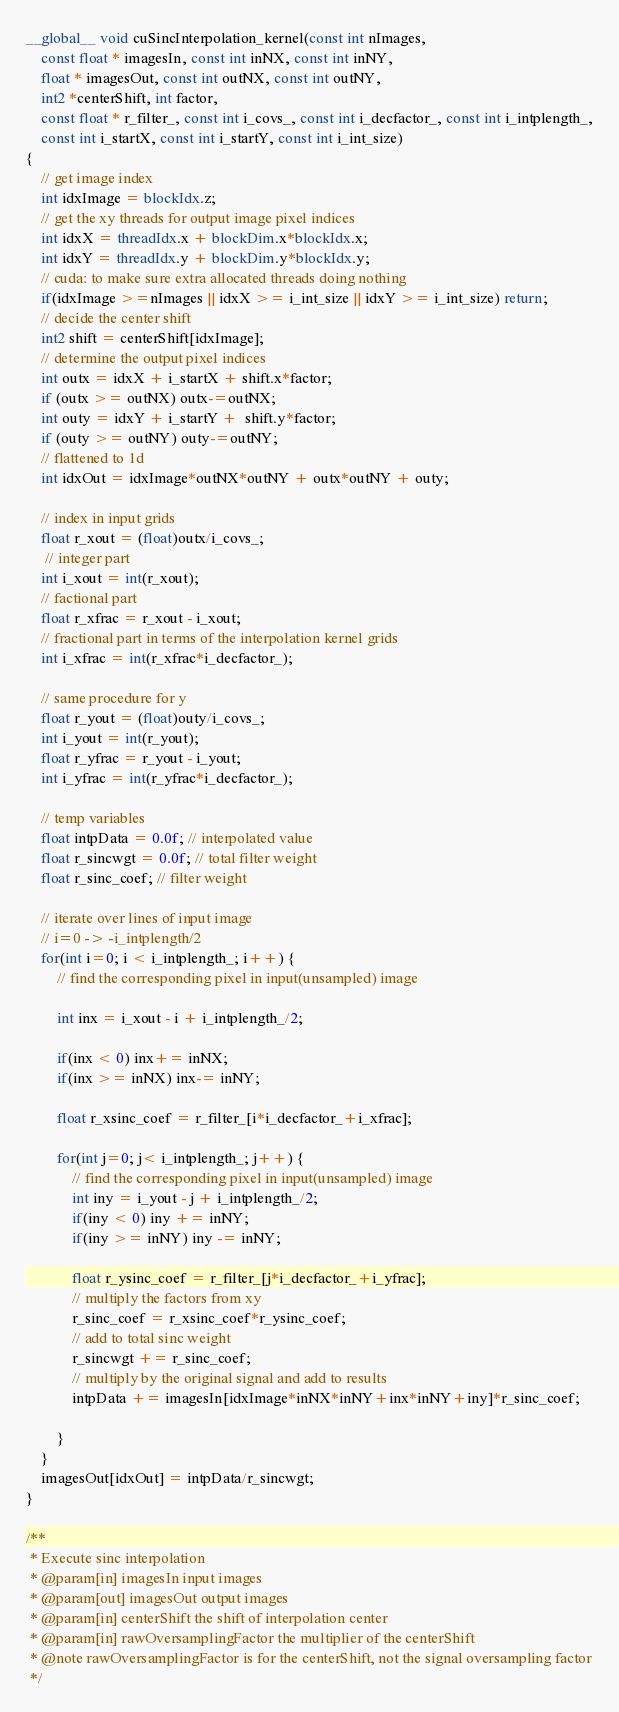Convert code to text. <code><loc_0><loc_0><loc_500><loc_500><_Cuda_>__global__ void cuSincInterpolation_kernel(const int nImages,
    const float * imagesIn, const int inNX, const int inNY,
    float * imagesOut, const int outNX, const int outNY,
    int2 *centerShift, int factor,
    const float * r_filter_, const int i_covs_, const int i_decfactor_, const int i_intplength_,
    const int i_startX, const int i_startY, const int i_int_size)
{
    // get image index
    int idxImage = blockIdx.z;
    // get the xy threads for output image pixel indices
    int idxX = threadIdx.x + blockDim.x*blockIdx.x;
    int idxY = threadIdx.y + blockDim.y*blockIdx.y;
    // cuda: to make sure extra allocated threads doing nothing
    if(idxImage >=nImages || idxX >= i_int_size || idxY >= i_int_size) return;
    // decide the center shift
    int2 shift = centerShift[idxImage];
    // determine the output pixel indices
    int outx = idxX + i_startX + shift.x*factor;
    if (outx >= outNX) outx-=outNX;
    int outy = idxY + i_startY +  shift.y*factor;
    if (outy >= outNY) outy-=outNY;
    // flattened to 1d
    int idxOut = idxImage*outNX*outNY + outx*outNY + outy;

    // index in input grids
    float r_xout = (float)outx/i_covs_;
     // integer part
    int i_xout = int(r_xout);
    // factional part
    float r_xfrac = r_xout - i_xout;
    // fractional part in terms of the interpolation kernel grids
    int i_xfrac = int(r_xfrac*i_decfactor_);

    // same procedure for y
    float r_yout = (float)outy/i_covs_;
    int i_yout = int(r_yout);
    float r_yfrac = r_yout - i_yout;
    int i_yfrac = int(r_yfrac*i_decfactor_);

    // temp variables
    float intpData = 0.0f; // interpolated value
    float r_sincwgt = 0.0f; // total filter weight
    float r_sinc_coef; // filter weight

    // iterate over lines of input image
    // i=0 -> -i_intplength/2
    for(int i=0; i < i_intplength_; i++) {
        // find the corresponding pixel in input(unsampled) image

        int inx = i_xout - i + i_intplength_/2;

        if(inx < 0) inx+= inNX;
        if(inx >= inNX) inx-= inNY;

        float r_xsinc_coef = r_filter_[i*i_decfactor_+i_xfrac];

        for(int j=0; j< i_intplength_; j++) {
            // find the corresponding pixel in input(unsampled) image
            int iny = i_yout - j + i_intplength_/2;
            if(iny < 0) iny += inNY;
            if(iny >= inNY) iny -= inNY;

            float r_ysinc_coef = r_filter_[j*i_decfactor_+i_yfrac];
            // multiply the factors from xy
            r_sinc_coef = r_xsinc_coef*r_ysinc_coef;
            // add to total sinc weight
            r_sincwgt += r_sinc_coef;
            // multiply by the original signal and add to results
            intpData += imagesIn[idxImage*inNX*inNY+inx*inNY+iny]*r_sinc_coef;

        }
    }
    imagesOut[idxOut] = intpData/r_sincwgt;
}

/**
 * Execute sinc interpolation
 * @param[in] imagesIn input images
 * @param[out] imagesOut output images
 * @param[in] centerShift the shift of interpolation center
 * @param[in] rawOversamplingFactor the multiplier of the centerShift
 * @note rawOversamplingFactor is for the centerShift, not the signal oversampling factor
 */
</code> 